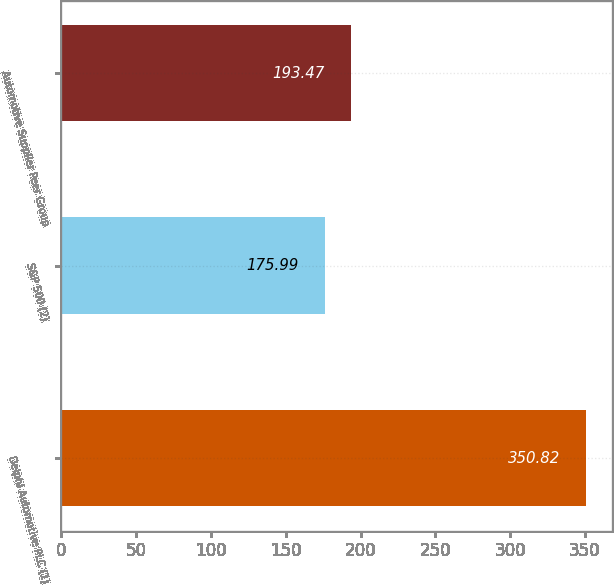<chart> <loc_0><loc_0><loc_500><loc_500><bar_chart><fcel>Delphi Automotive PLC (1)<fcel>S&P 500 (2)<fcel>Automotive Supplier Peer Group<nl><fcel>350.82<fcel>175.99<fcel>193.47<nl></chart> 